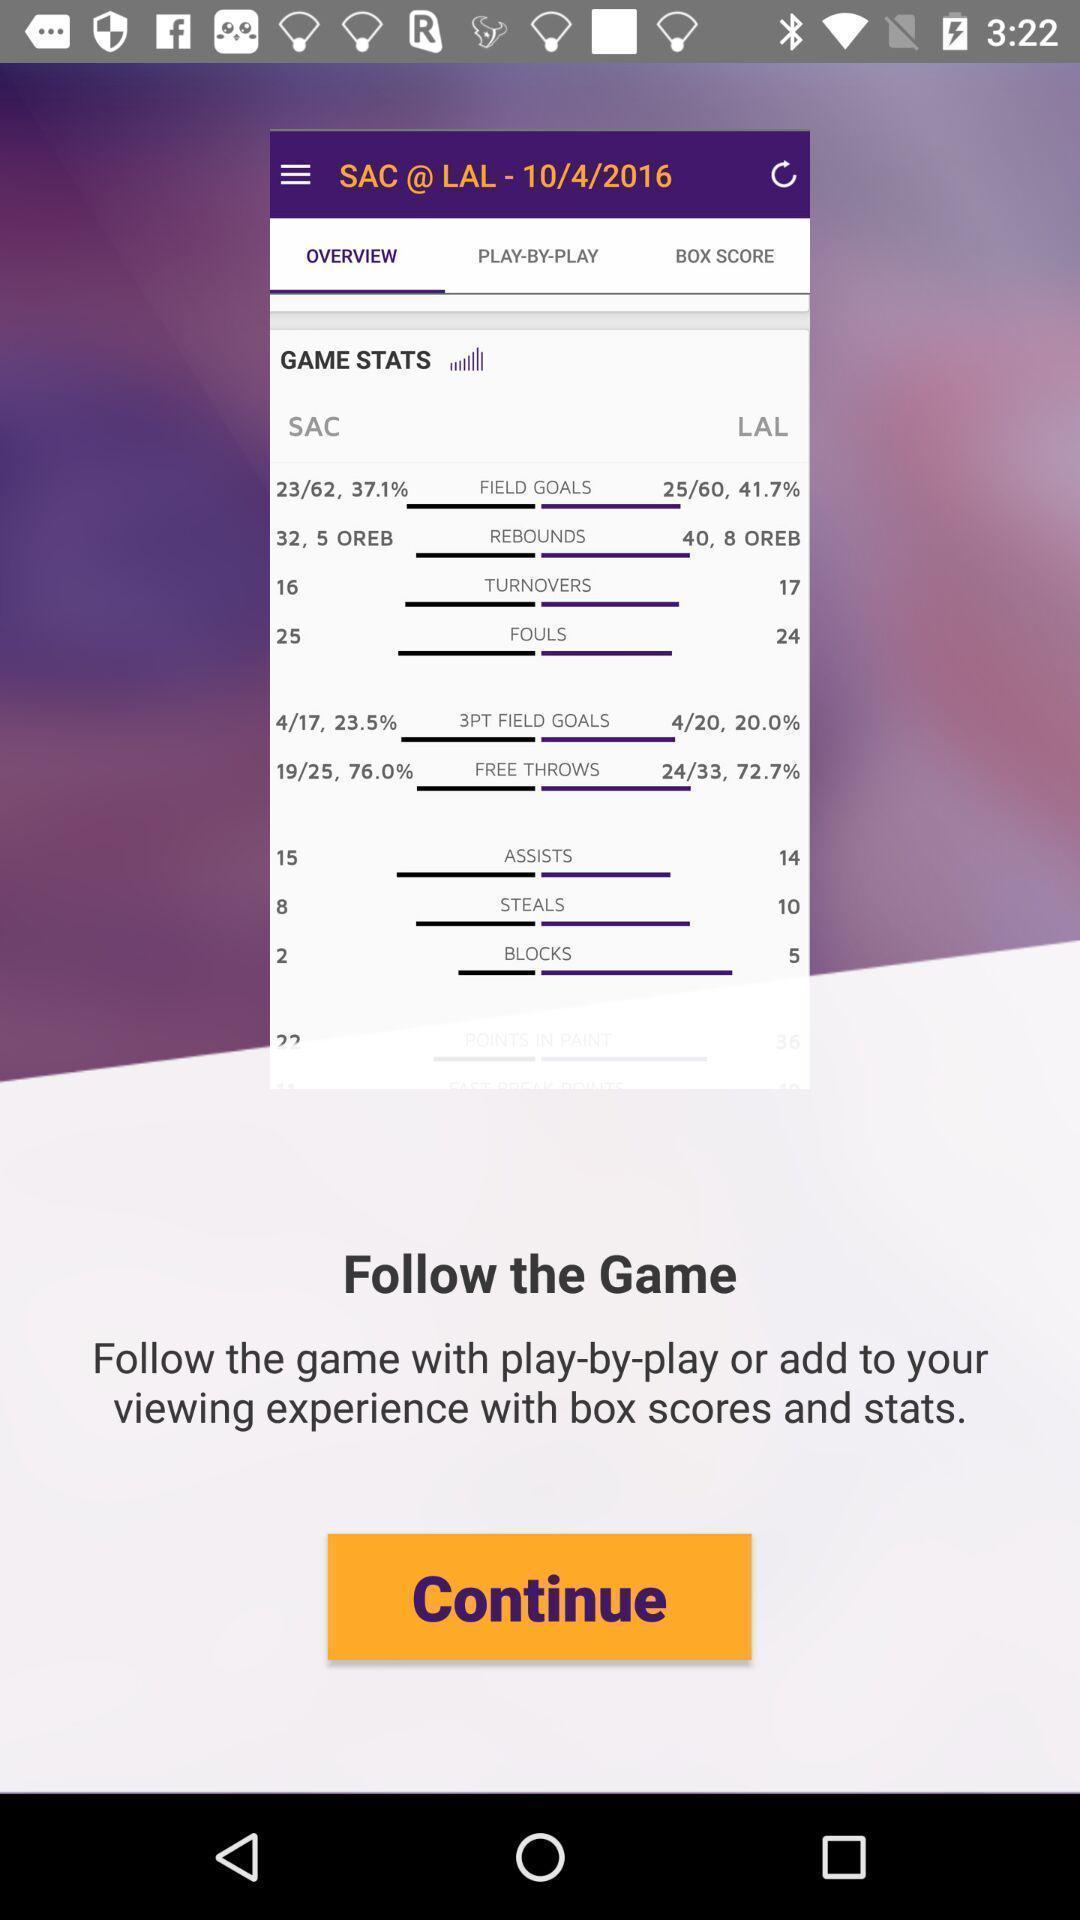Summarize the main components in this picture. Welcome page for a sports team. 